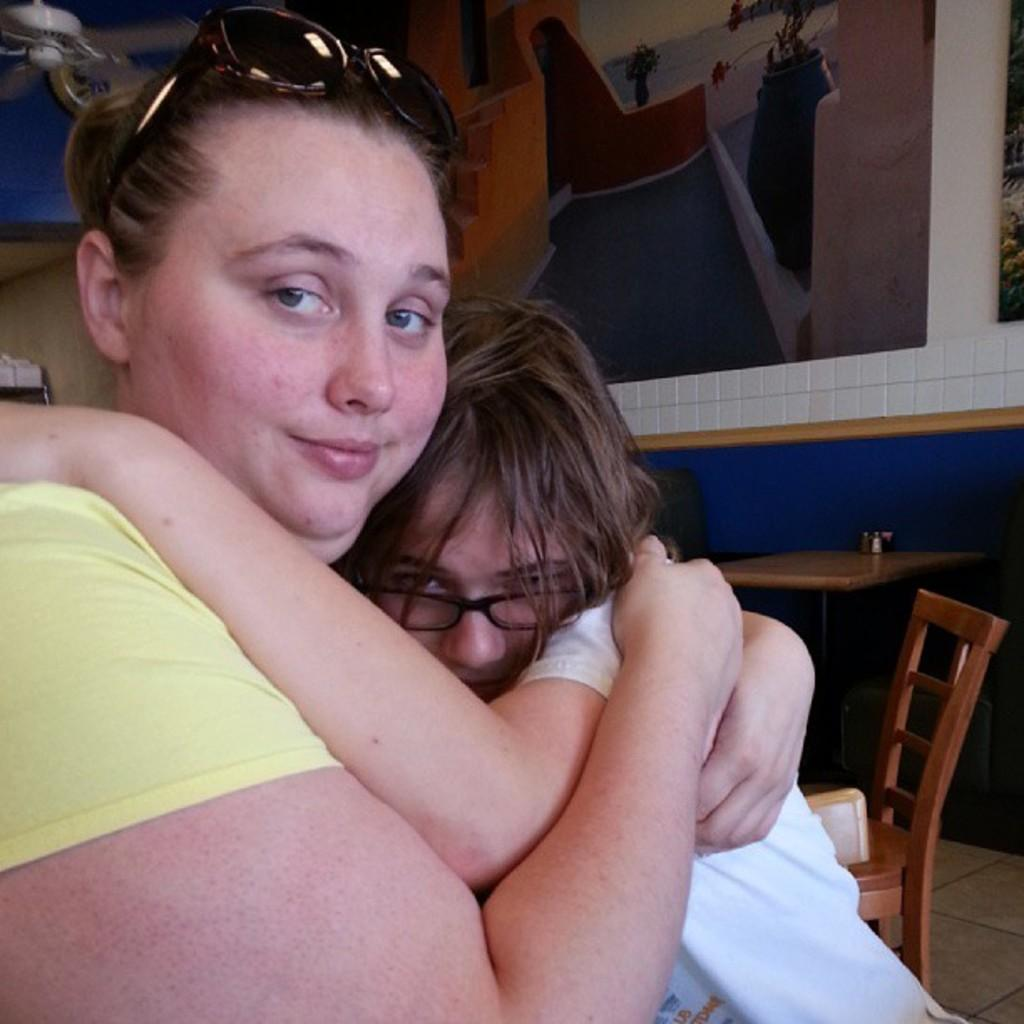What is happening between the woman and the girl in the image? The woman is hugging a girl in the image. What can be seen in the background of the image? There is a wall, frames, a table, and a chair in the background of the image. What is depicted within the frames in the background? In the frame, there is a staircase, a plant, a flower vase, water, and sky. What type of protest is happening in the image? There is no protest depicted in the image; it shows a woman hugging a girl and various objects in the background. How many trains can be seen in the image? There are no trains present in the image. 